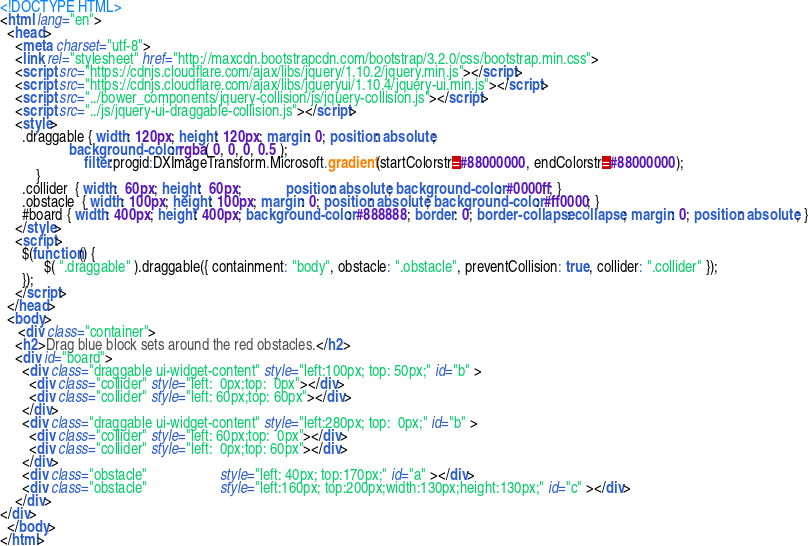Convert code to text. <code><loc_0><loc_0><loc_500><loc_500><_HTML_><!DOCTYPE HTML>
<html lang="en">
  <head>
    <meta charset="utf-8">
    <link rel="stylesheet" href="http://maxcdn.bootstrapcdn.com/bootstrap/3.2.0/css/bootstrap.min.css">
    <script src="https://cdnjs.cloudflare.com/ajax/libs/jquery/1.10.2/jquery.min.js"></script>
    <script src="https://cdnjs.cloudflare.com/ajax/libs/jqueryui/1.10.4/jquery-ui.min.js"></script>
    <script src="../bower_components/jquery-collision/js/jquery-collision.js"></script>
    <script src="../js/jquery-ui-draggable-collision.js"></script>
    <style>
      .draggable { width: 120px; height: 120px; margin: 0; position: absolute;
                   background-color: rgba( 0, 0, 0, 0.5 );
		               filter:progid:DXImageTransform.Microsoft.gradient(startColorstr=#88000000, endColorstr=#88000000);
		  }
      .collider  { width:  60px; height:  60px;            position: absolute; background-color: #0000ff; }
      .obstacle  { width: 100px; height: 100px; margin: 0; position: absolute; background-color: #ff0000; }
      #board { width: 400px; height: 400px; background-color: #888888; border: 0; border-collapse: collapse; margin: 0; position: absolute; }
    </style>
    <script>
      $(function() {
            $( ".draggable" ).draggable({ containment: "body", obstacle: ".obstacle", preventCollision: true, collider: ".collider" });
      });
    </script>
  </head>
  <body>
     <div class="container">
    <h2>Drag blue block sets around the red obstacles.</h2>
    <div id="board">
      <div class="draggable ui-widget-content" style="left:100px; top: 50px;" id="b" >
        <div class="collider" style="left:  0px;top:  0px"></div>
        <div class="collider" style="left: 60px;top: 60px"></div>
      </div>
      <div class="draggable ui-widget-content" style="left:280px; top:  0px;" id="b" >
        <div class="collider" style="left: 60px;top:  0px"></div>
        <div class="collider" style="left:  0px;top: 60px"></div>
      </div>
      <div class="obstacle"                    style="left: 40px; top:170px;" id="a" ></div>
      <div class="obstacle"                    style="left:160px; top:200px;width:130px;height:130px;" id="c" ></div>
    </div>
</div>
  </body>
</html>
</code> 